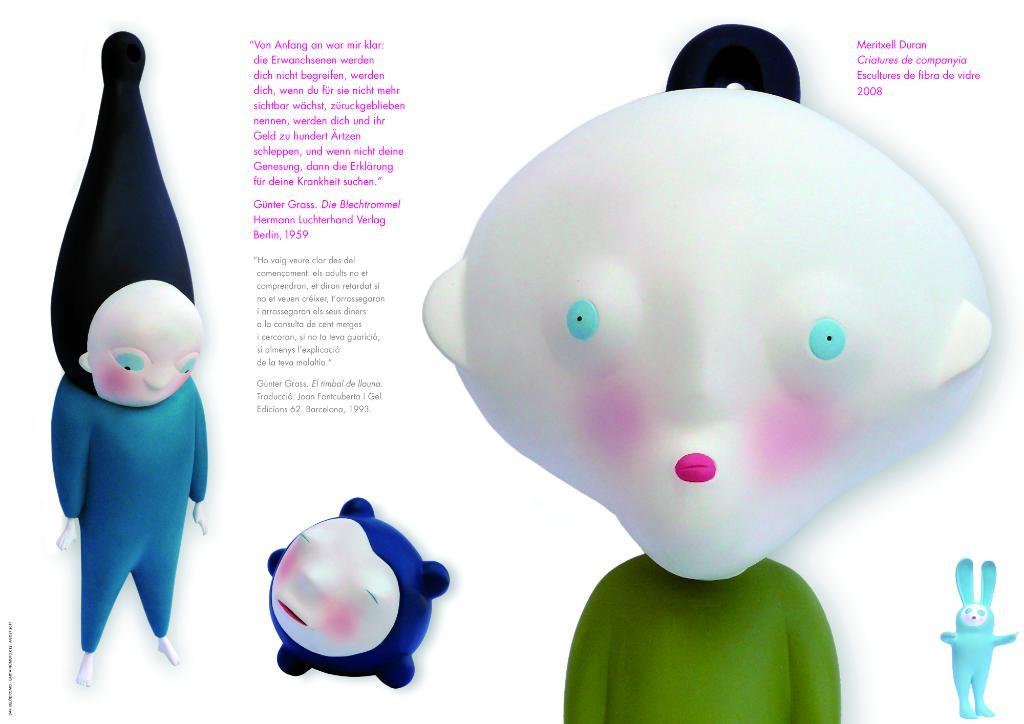What can be found on the image that contains written information? There is text written on the image. What type of images are present in the picture? There are animated images in the picture. Can you see a rat in the image? There is no rat present in the image. Is there any quicksand visible in the image? There is no quicksand present in the image. 